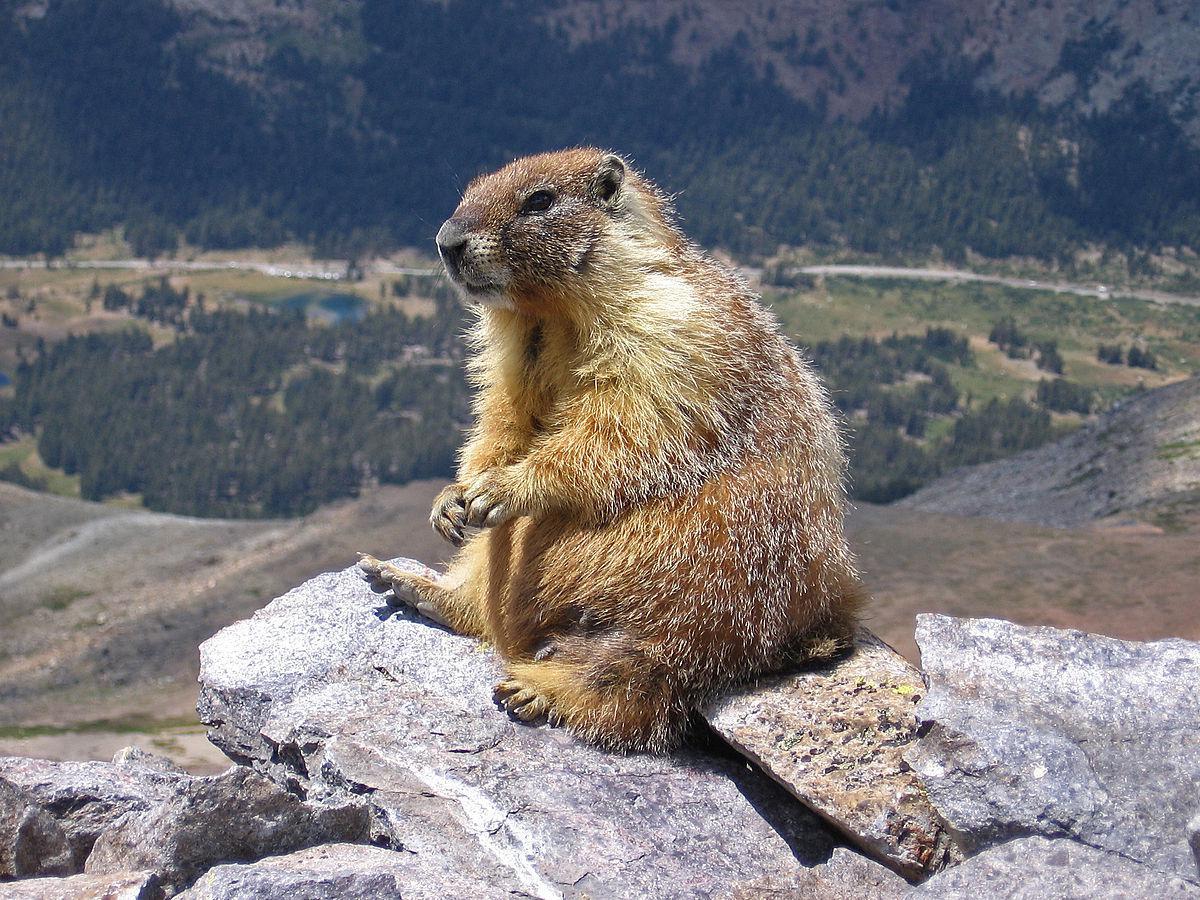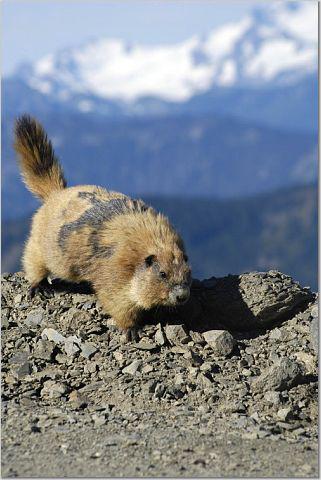The first image is the image on the left, the second image is the image on the right. Assess this claim about the two images: "There are two animals total.". Correct or not? Answer yes or no. Yes. 